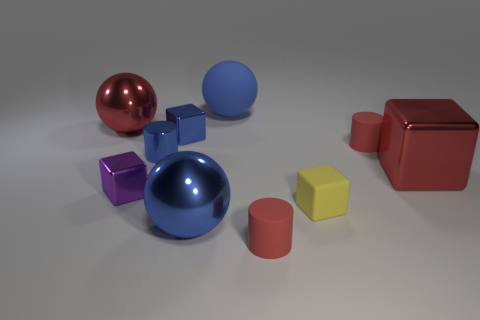Are there fewer big blue things on the right side of the tiny matte cube than red balls?
Your answer should be compact. Yes. What shape is the tiny purple shiny object?
Give a very brief answer. Cube. What size is the red metal object in front of the large red shiny ball?
Keep it short and to the point. Large. What is the color of the metal cylinder that is the same size as the rubber cube?
Your answer should be very brief. Blue. Are there any cylinders that have the same color as the rubber ball?
Your response must be concise. Yes. Is the number of purple metallic objects that are right of the yellow cube less than the number of tiny matte objects that are behind the blue cube?
Keep it short and to the point. No. There is a sphere that is both right of the purple metallic object and in front of the blue matte thing; what is its material?
Offer a very short reply. Metal. Is the shape of the big matte thing the same as the tiny red rubber thing left of the yellow matte block?
Provide a short and direct response. No. What number of other objects are there of the same size as the red block?
Offer a terse response. 3. Are there more tiny purple metal cylinders than tiny blue things?
Provide a short and direct response. No. 